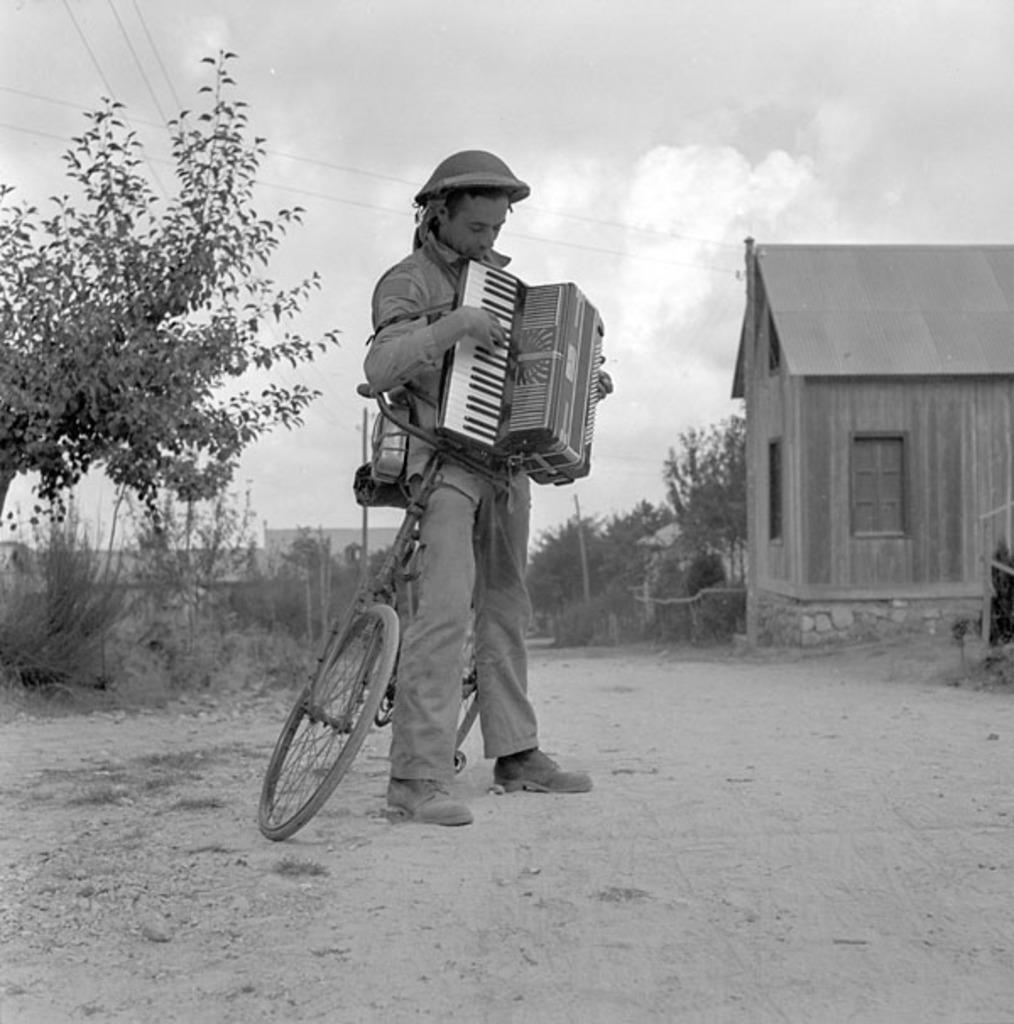What is the person in the image doing? The person is holding a music instrument. What is the person standing next to? The person is standing next to a cycle. What type of structure can be seen in the image? There is a house in the image. What type of vegetation is present in the image? There are trees and plants in the image. What other objects can be seen in the image? There are poles in the image. Can you see a chicken wearing a crown in the image? There is no chicken or crown present in the image. Is the person in the image crying? There is no indication in the image that the person is crying. 